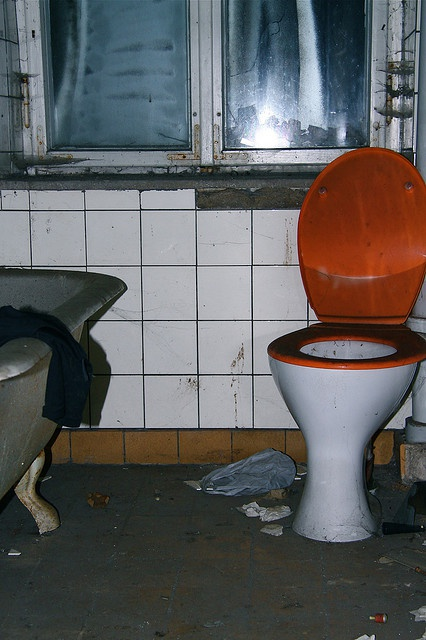Describe the objects in this image and their specific colors. I can see toilet in purple, maroon, darkgray, and black tones and sink in purple and black tones in this image. 